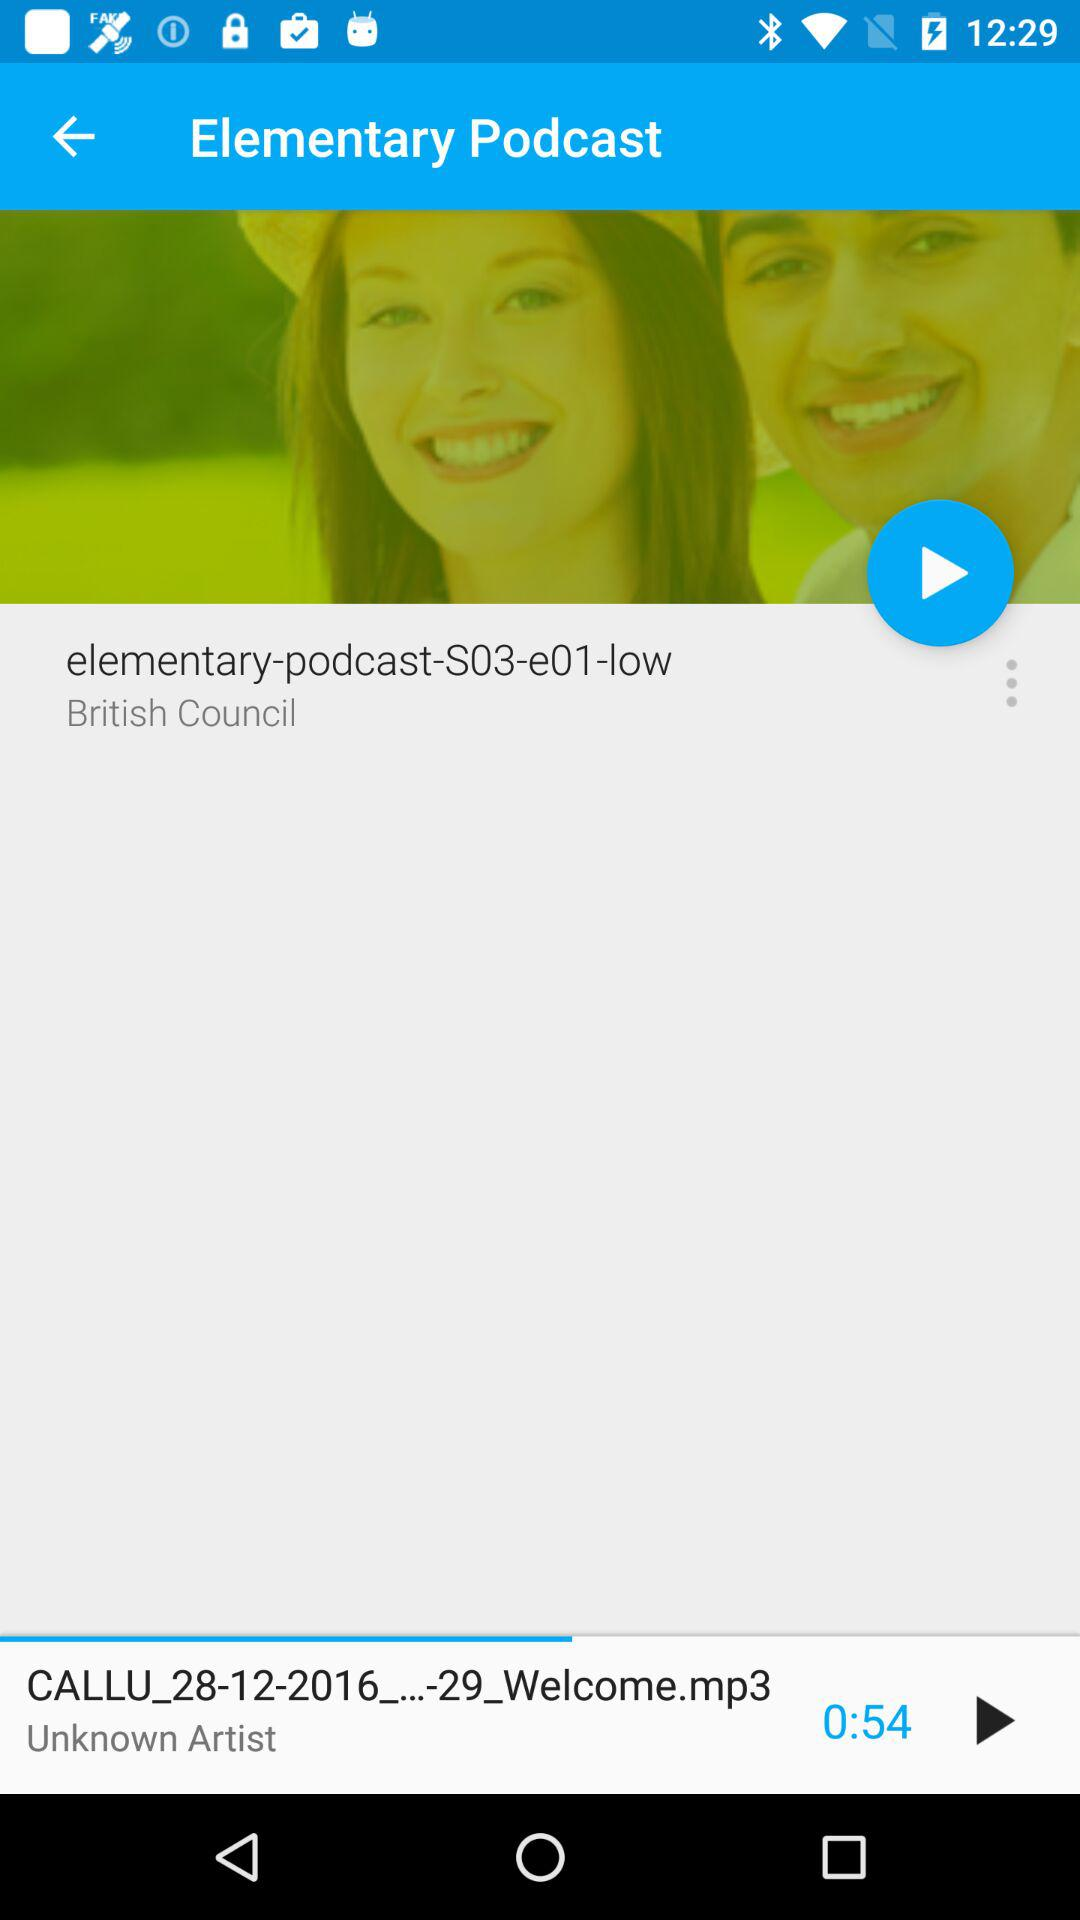What is the duration of the clip? The duration of the clip is 54 seconds. 